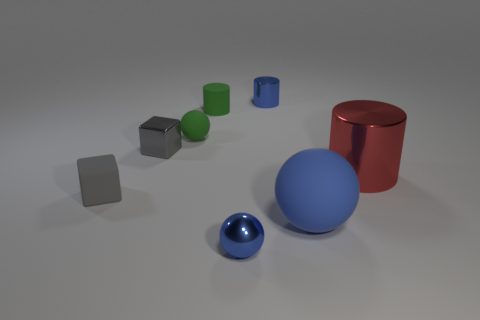Add 1 big matte blocks. How many objects exist? 9 Subtract all cylinders. How many objects are left? 5 Subtract 0 green blocks. How many objects are left? 8 Subtract all blue shiny cubes. Subtract all tiny cubes. How many objects are left? 6 Add 1 green rubber spheres. How many green rubber spheres are left? 2 Add 2 gray cubes. How many gray cubes exist? 4 